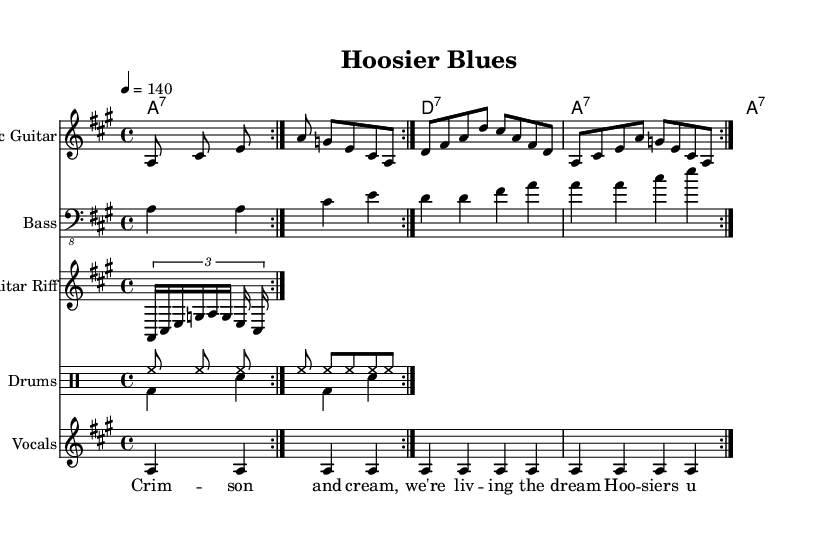What is the key signature of this music? The key signature is A major, which has three sharps (C#, F#, and G#). In the sheet music, the key is indicated at the beginning, showing the notes corresponding to the A major scale.
Answer: A major What is the time signature of this music? The time signature is 4/4, which means there are four beats in each measure and each quarter note receives one beat. This is indicated at the beginning of the score near the key signature.
Answer: 4/4 What is the tempo marking of this piece? The tempo marking is 140 beats per minute, indicated by the "tempo 4 = 140" notation at the start of the score. This tells performers how fast the piece should be played.
Answer: 140 How many times is the main electric guitar riff repeated? The electric guitar riff is repeated two times, as indicated by the "repeat volta 2" notation appearing in the sections for the electric guitar part. This notation signifies that the player should play that section twice.
Answer: 2 What type of guitar is featured prominently in this music? The music prominently features an electric guitar, as indicated in the instrument name on the staff. The specific riff and chords also suggest that the guitarist would be playing with an electric sound appropriate for the Blues genre.
Answer: Electric guitar What are the lyrics for the choir in this piece? The lyrics for the choir are "Crimson and cream, we're living the dream, Hoosiers unite, our spirit burns bright." These lyrics are set to the vocal line in the sheet music and reflect the camaraderie and team spirit central to electric blues anthems.
Answer: Crimson and cream, we're living the dream, Hoosiers unite, our spirit burns bright What is the primary theme of this electric blues anthem? The primary theme of this electric blues anthem is celebrating team spirit and camaraderie, as expressed through the lyrics and the upbeat style of the music. The lyrics specifically invoke the colors and spirit of the IU team, reflecting a collective pride and unity.
Answer: Celebration of team spirit 